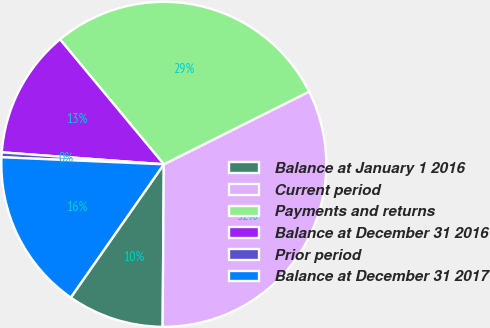Convert chart to OTSL. <chart><loc_0><loc_0><loc_500><loc_500><pie_chart><fcel>Balance at January 1 2016<fcel>Current period<fcel>Payments and returns<fcel>Balance at December 31 2016<fcel>Prior period<fcel>Balance at December 31 2017<nl><fcel>9.59%<fcel>32.5%<fcel>28.65%<fcel>12.79%<fcel>0.48%<fcel>15.99%<nl></chart> 